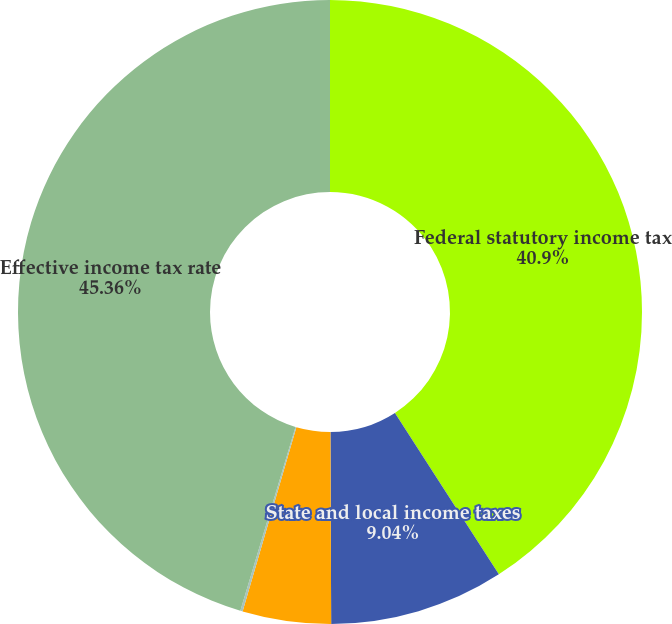Convert chart to OTSL. <chart><loc_0><loc_0><loc_500><loc_500><pie_chart><fcel>Federal statutory income tax<fcel>State and local income taxes<fcel>Nondeductible and other items<fcel>Credits<fcel>Effective income tax rate<nl><fcel>40.9%<fcel>9.04%<fcel>4.58%<fcel>0.12%<fcel>45.36%<nl></chart> 